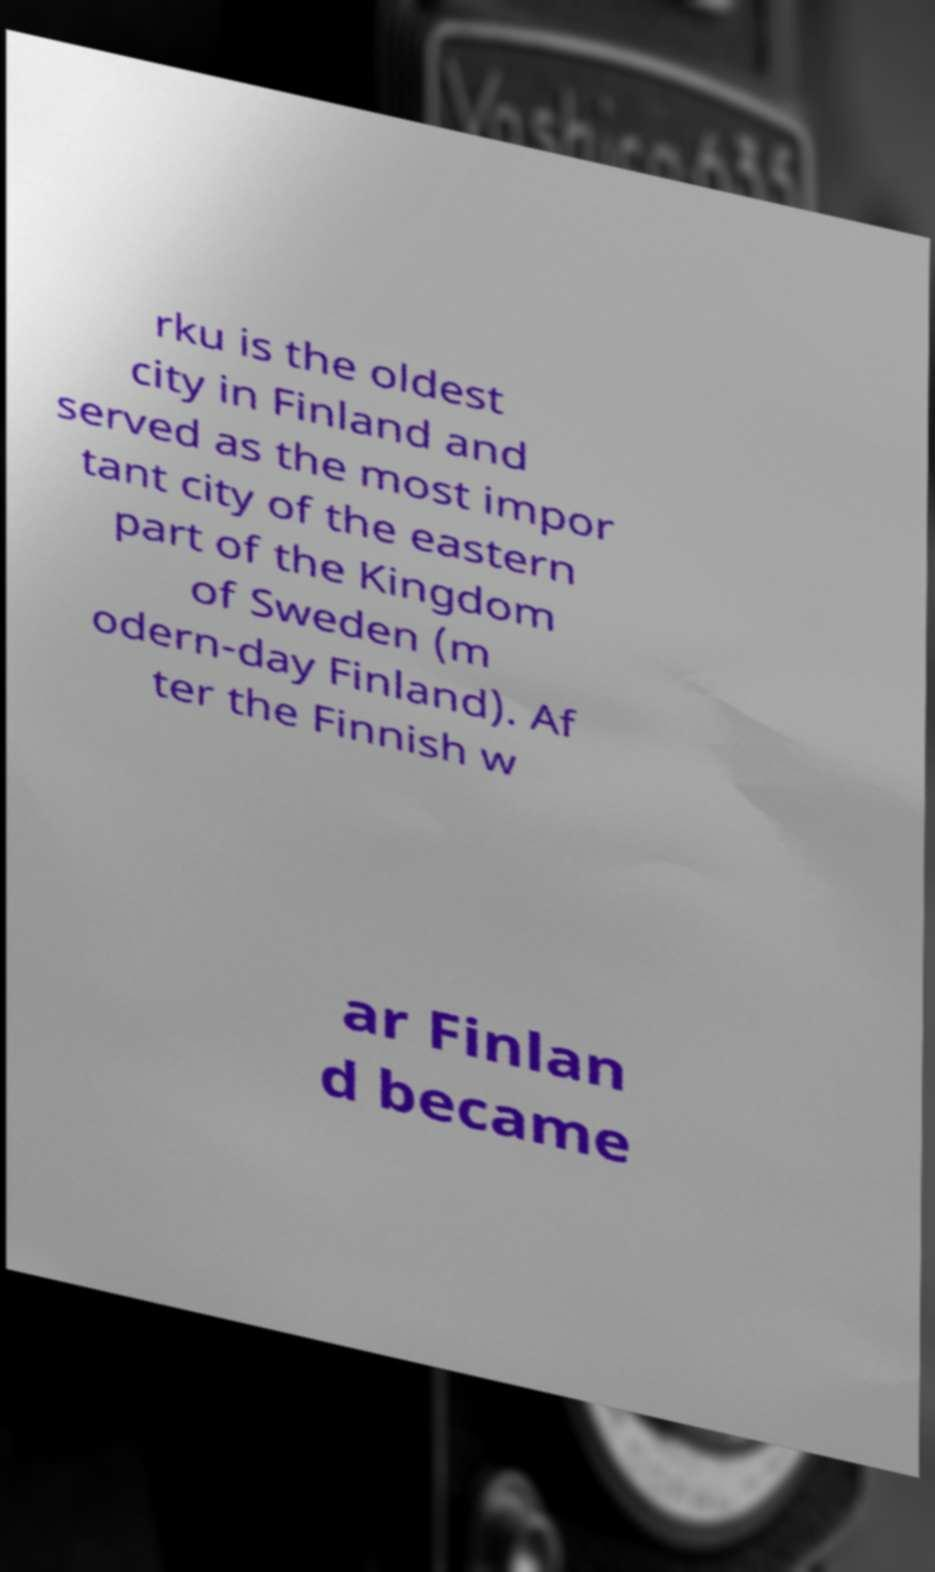For documentation purposes, I need the text within this image transcribed. Could you provide that? rku is the oldest city in Finland and served as the most impor tant city of the eastern part of the Kingdom of Sweden (m odern-day Finland). Af ter the Finnish w ar Finlan d became 